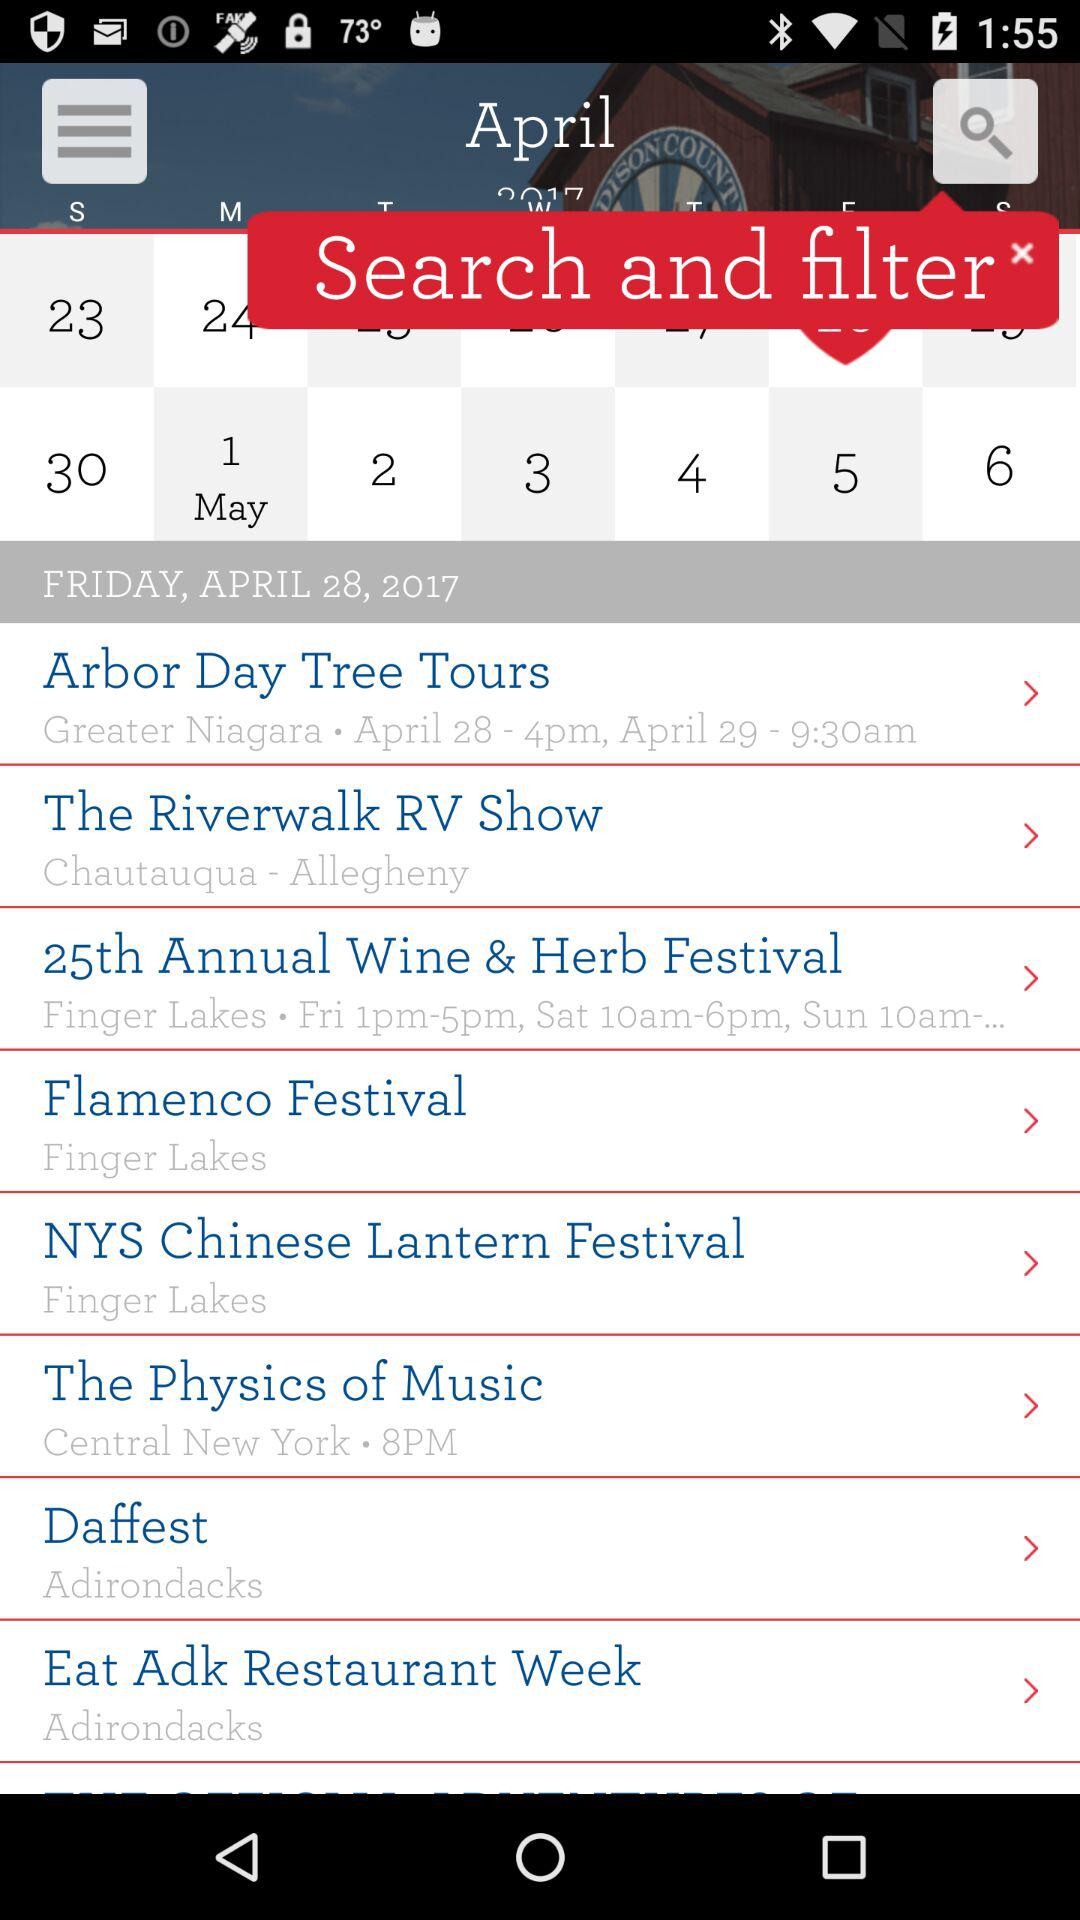What is the timing given for the "25th Annual Wine & Herb Festival"? The given timings are 1 p.m. to 5 p.m. on Friday and 10 a.m. to 6 p.m. on Saturday. 